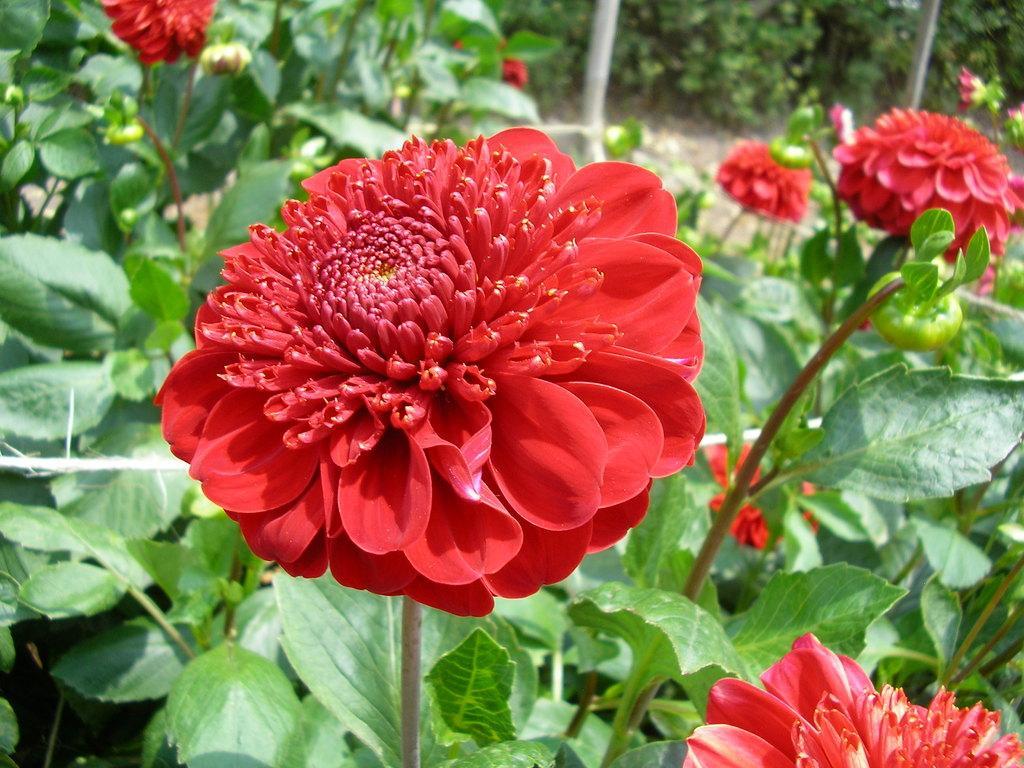Please provide a concise description of this image. In this image there are plants and we can see flowers which are in red color. 